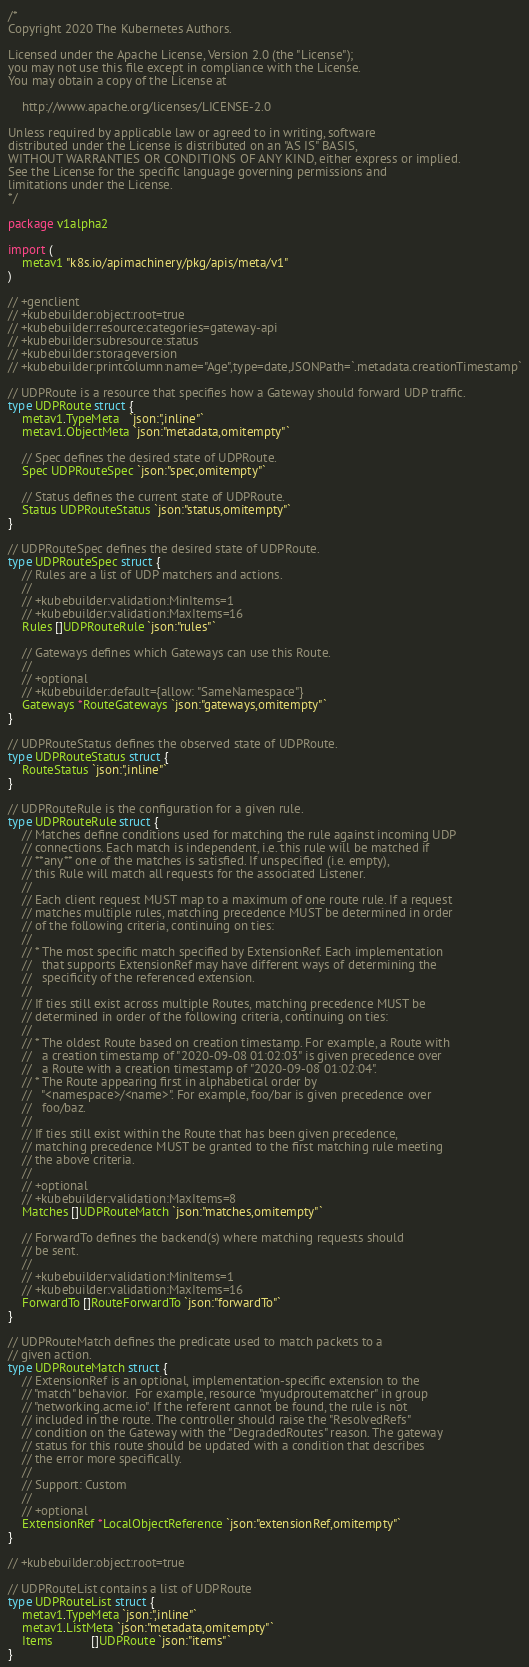Convert code to text. <code><loc_0><loc_0><loc_500><loc_500><_Go_>/*
Copyright 2020 The Kubernetes Authors.

Licensed under the Apache License, Version 2.0 (the "License");
you may not use this file except in compliance with the License.
You may obtain a copy of the License at

    http://www.apache.org/licenses/LICENSE-2.0

Unless required by applicable law or agreed to in writing, software
distributed under the License is distributed on an "AS IS" BASIS,
WITHOUT WARRANTIES OR CONDITIONS OF ANY KIND, either express or implied.
See the License for the specific language governing permissions and
limitations under the License.
*/

package v1alpha2

import (
	metav1 "k8s.io/apimachinery/pkg/apis/meta/v1"
)

// +genclient
// +kubebuilder:object:root=true
// +kubebuilder:resource:categories=gateway-api
// +kubebuilder:subresource:status
// +kubebuilder:storageversion
// +kubebuilder:printcolumn:name="Age",type=date,JSONPath=`.metadata.creationTimestamp`

// UDPRoute is a resource that specifies how a Gateway should forward UDP traffic.
type UDPRoute struct {
	metav1.TypeMeta   `json:",inline"`
	metav1.ObjectMeta `json:"metadata,omitempty"`

	// Spec defines the desired state of UDPRoute.
	Spec UDPRouteSpec `json:"spec,omitempty"`

	// Status defines the current state of UDPRoute.
	Status UDPRouteStatus `json:"status,omitempty"`
}

// UDPRouteSpec defines the desired state of UDPRoute.
type UDPRouteSpec struct {
	// Rules are a list of UDP matchers and actions.
	//
	// +kubebuilder:validation:MinItems=1
	// +kubebuilder:validation:MaxItems=16
	Rules []UDPRouteRule `json:"rules"`

	// Gateways defines which Gateways can use this Route.
	//
	// +optional
	// +kubebuilder:default={allow: "SameNamespace"}
	Gateways *RouteGateways `json:"gateways,omitempty"`
}

// UDPRouteStatus defines the observed state of UDPRoute.
type UDPRouteStatus struct {
	RouteStatus `json:",inline"`
}

// UDPRouteRule is the configuration for a given rule.
type UDPRouteRule struct {
	// Matches define conditions used for matching the rule against incoming UDP
	// connections. Each match is independent, i.e. this rule will be matched if
	// **any** one of the matches is satisfied. If unspecified (i.e. empty),
	// this Rule will match all requests for the associated Listener.
	//
	// Each client request MUST map to a maximum of one route rule. If a request
	// matches multiple rules, matching precedence MUST be determined in order
	// of the following criteria, continuing on ties:
	//
	// * The most specific match specified by ExtensionRef. Each implementation
	//   that supports ExtensionRef may have different ways of determining the
	//   specificity of the referenced extension.
	//
	// If ties still exist across multiple Routes, matching precedence MUST be
	// determined in order of the following criteria, continuing on ties:
	//
	// * The oldest Route based on creation timestamp. For example, a Route with
	//   a creation timestamp of "2020-09-08 01:02:03" is given precedence over
	//   a Route with a creation timestamp of "2020-09-08 01:02:04".
	// * The Route appearing first in alphabetical order by
	//   "<namespace>/<name>". For example, foo/bar is given precedence over
	//   foo/baz.
	//
	// If ties still exist within the Route that has been given precedence,
	// matching precedence MUST be granted to the first matching rule meeting
	// the above criteria.
	//
	// +optional
	// +kubebuilder:validation:MaxItems=8
	Matches []UDPRouteMatch `json:"matches,omitempty"`

	// ForwardTo defines the backend(s) where matching requests should
	// be sent.
	//
	// +kubebuilder:validation:MinItems=1
	// +kubebuilder:validation:MaxItems=16
	ForwardTo []RouteForwardTo `json:"forwardTo"`
}

// UDPRouteMatch defines the predicate used to match packets to a
// given action.
type UDPRouteMatch struct {
	// ExtensionRef is an optional, implementation-specific extension to the
	// "match" behavior.  For example, resource "myudproutematcher" in group
	// "networking.acme.io". If the referent cannot be found, the rule is not
	// included in the route. The controller should raise the "ResolvedRefs"
	// condition on the Gateway with the "DegradedRoutes" reason. The gateway
	// status for this route should be updated with a condition that describes
	// the error more specifically.
	//
	// Support: Custom
	//
	// +optional
	ExtensionRef *LocalObjectReference `json:"extensionRef,omitempty"`
}

// +kubebuilder:object:root=true

// UDPRouteList contains a list of UDPRoute
type UDPRouteList struct {
	metav1.TypeMeta `json:",inline"`
	metav1.ListMeta `json:"metadata,omitempty"`
	Items           []UDPRoute `json:"items"`
}
</code> 